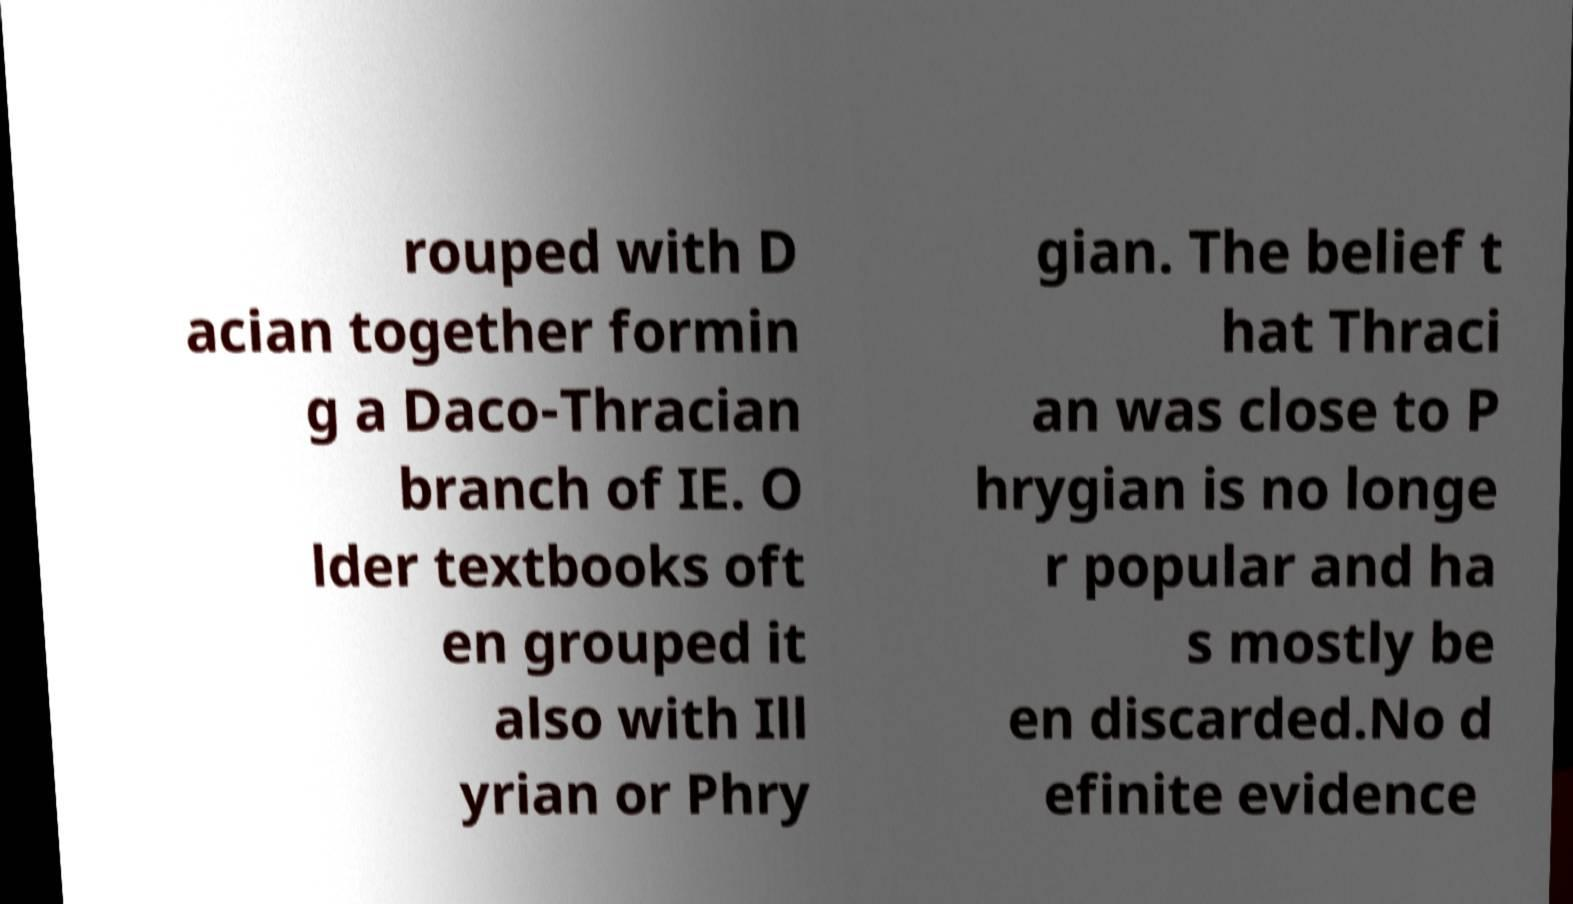I need the written content from this picture converted into text. Can you do that? rouped with D acian together formin g a Daco-Thracian branch of IE. O lder textbooks oft en grouped it also with Ill yrian or Phry gian. The belief t hat Thraci an was close to P hrygian is no longe r popular and ha s mostly be en discarded.No d efinite evidence 